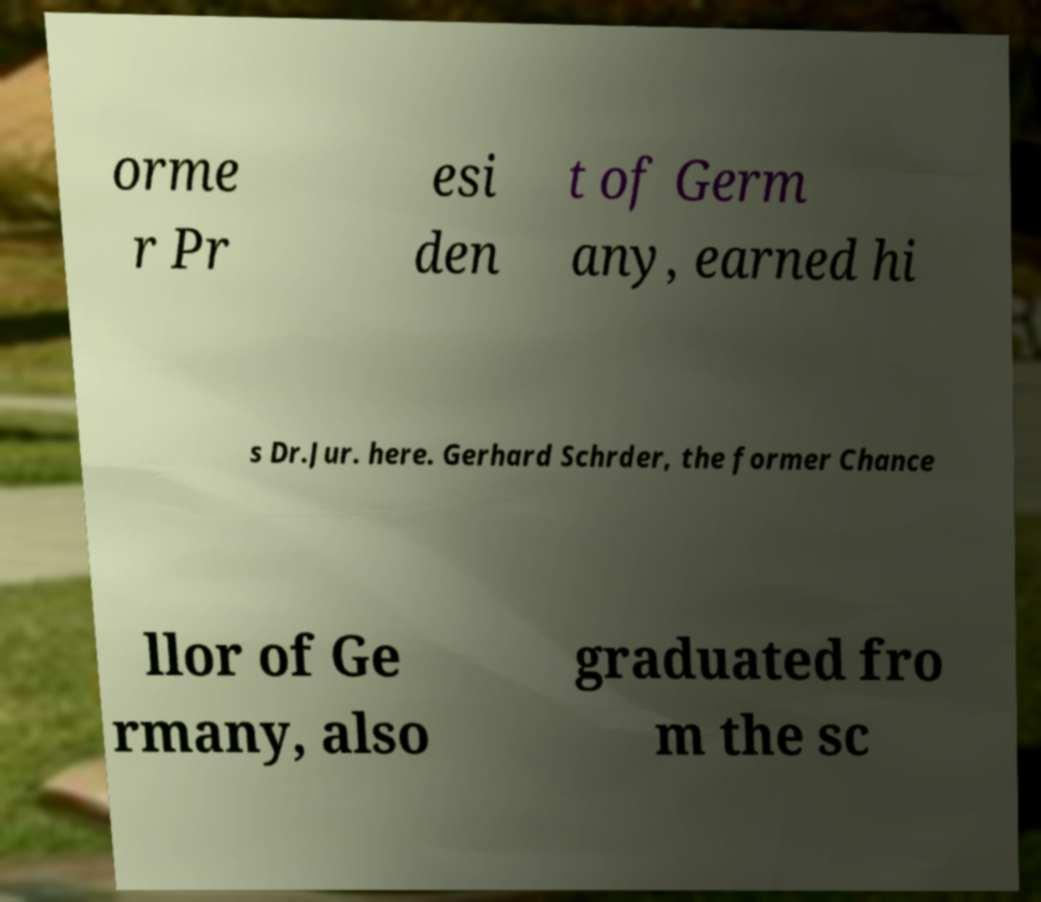I need the written content from this picture converted into text. Can you do that? orme r Pr esi den t of Germ any, earned hi s Dr.Jur. here. Gerhard Schrder, the former Chance llor of Ge rmany, also graduated fro m the sc 